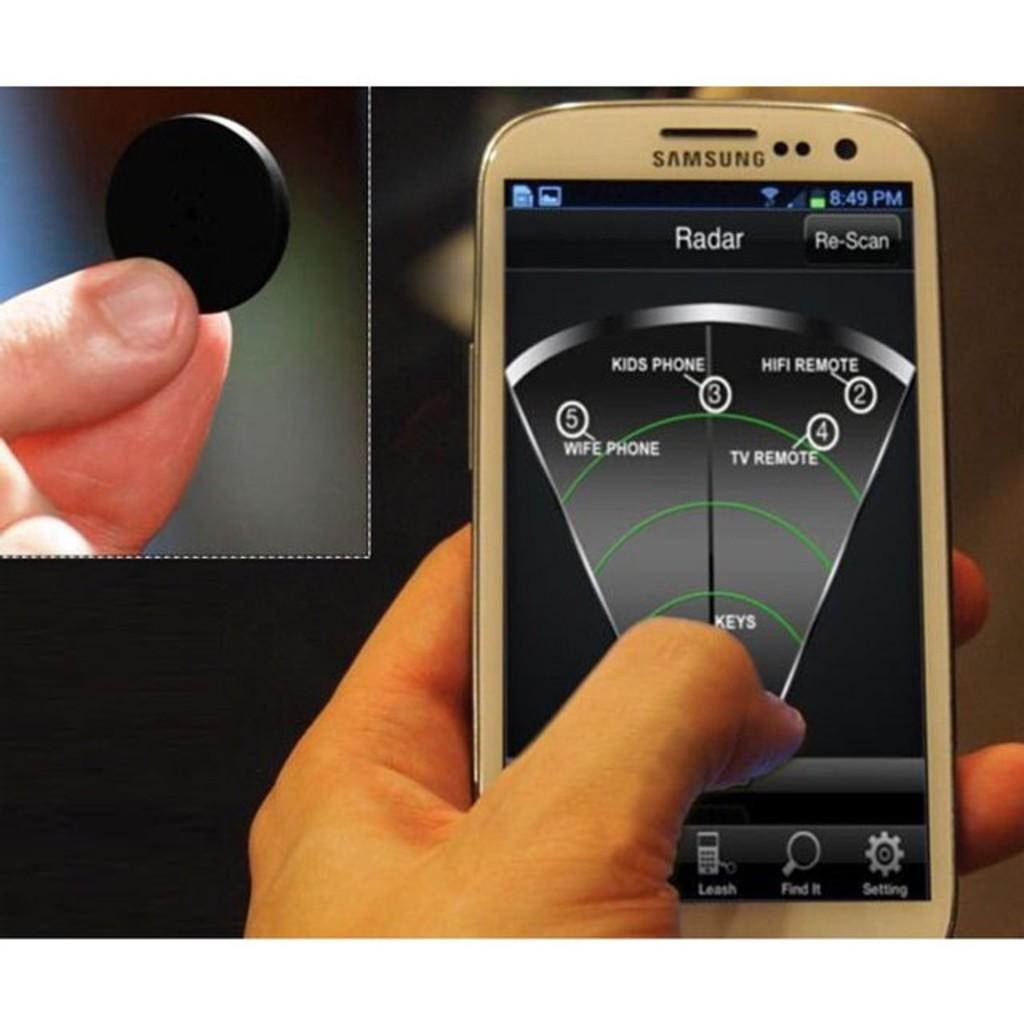<image>
Create a compact narrative representing the image presented. The person holds a samsung phone and is checking out the radar app. 